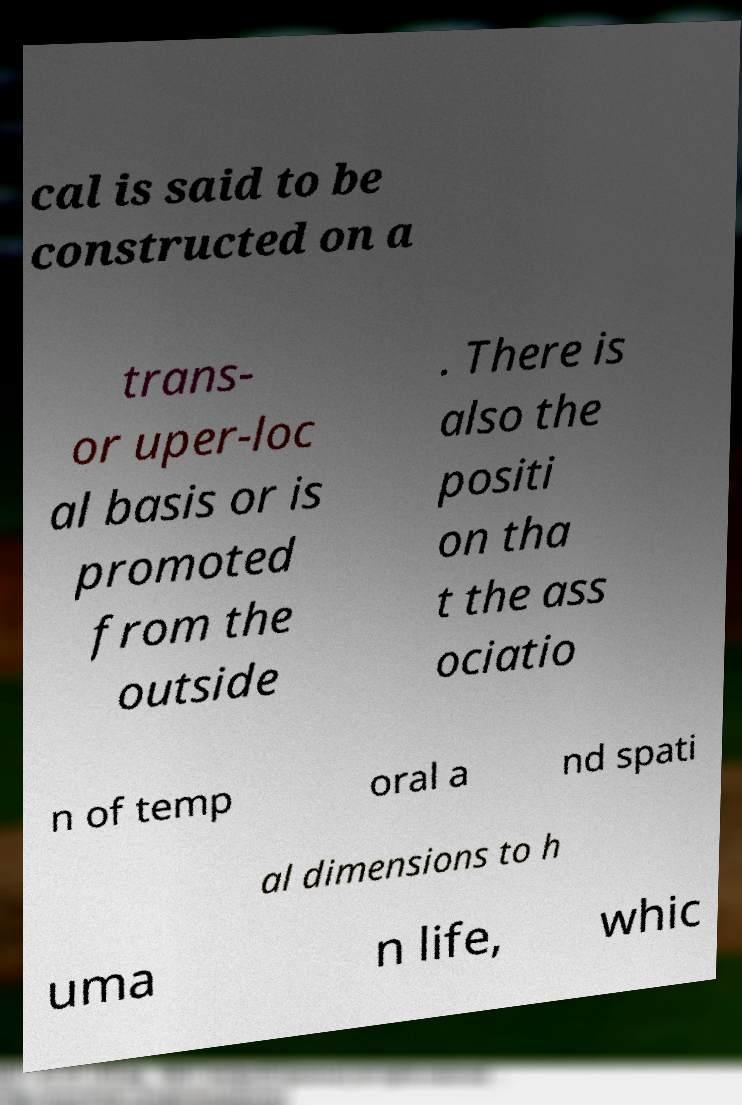What messages or text are displayed in this image? I need them in a readable, typed format. cal is said to be constructed on a trans- or uper-loc al basis or is promoted from the outside . There is also the positi on tha t the ass ociatio n of temp oral a nd spati al dimensions to h uma n life, whic 